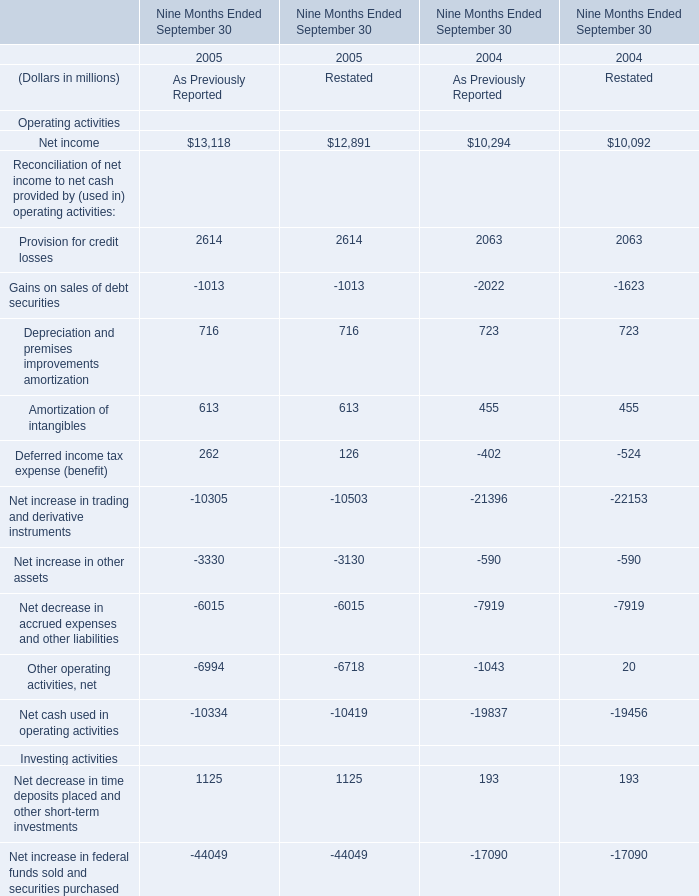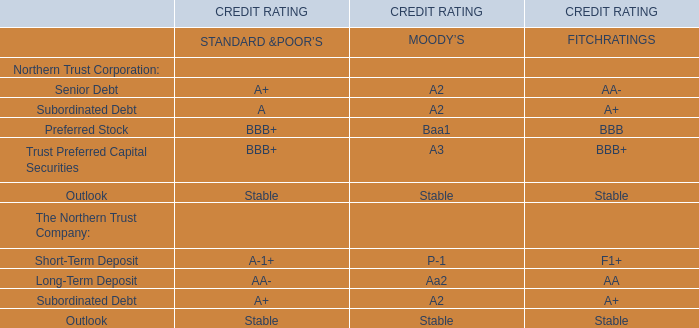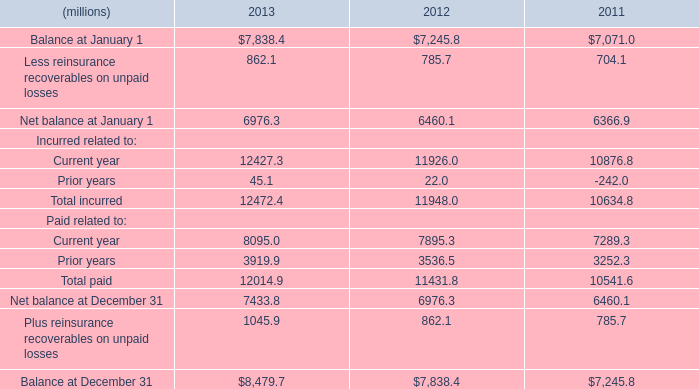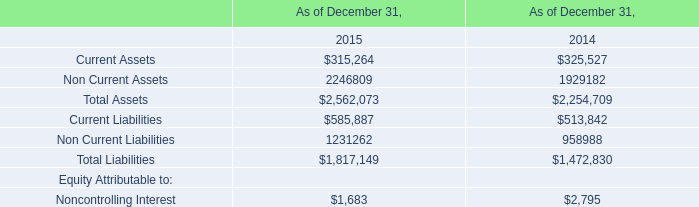What is the sum of Current Assets of As of December 31, 2014, and Net balance at January 1 of 2011 ? 
Computations: (325527.0 + 6366.9)
Answer: 331893.9. 